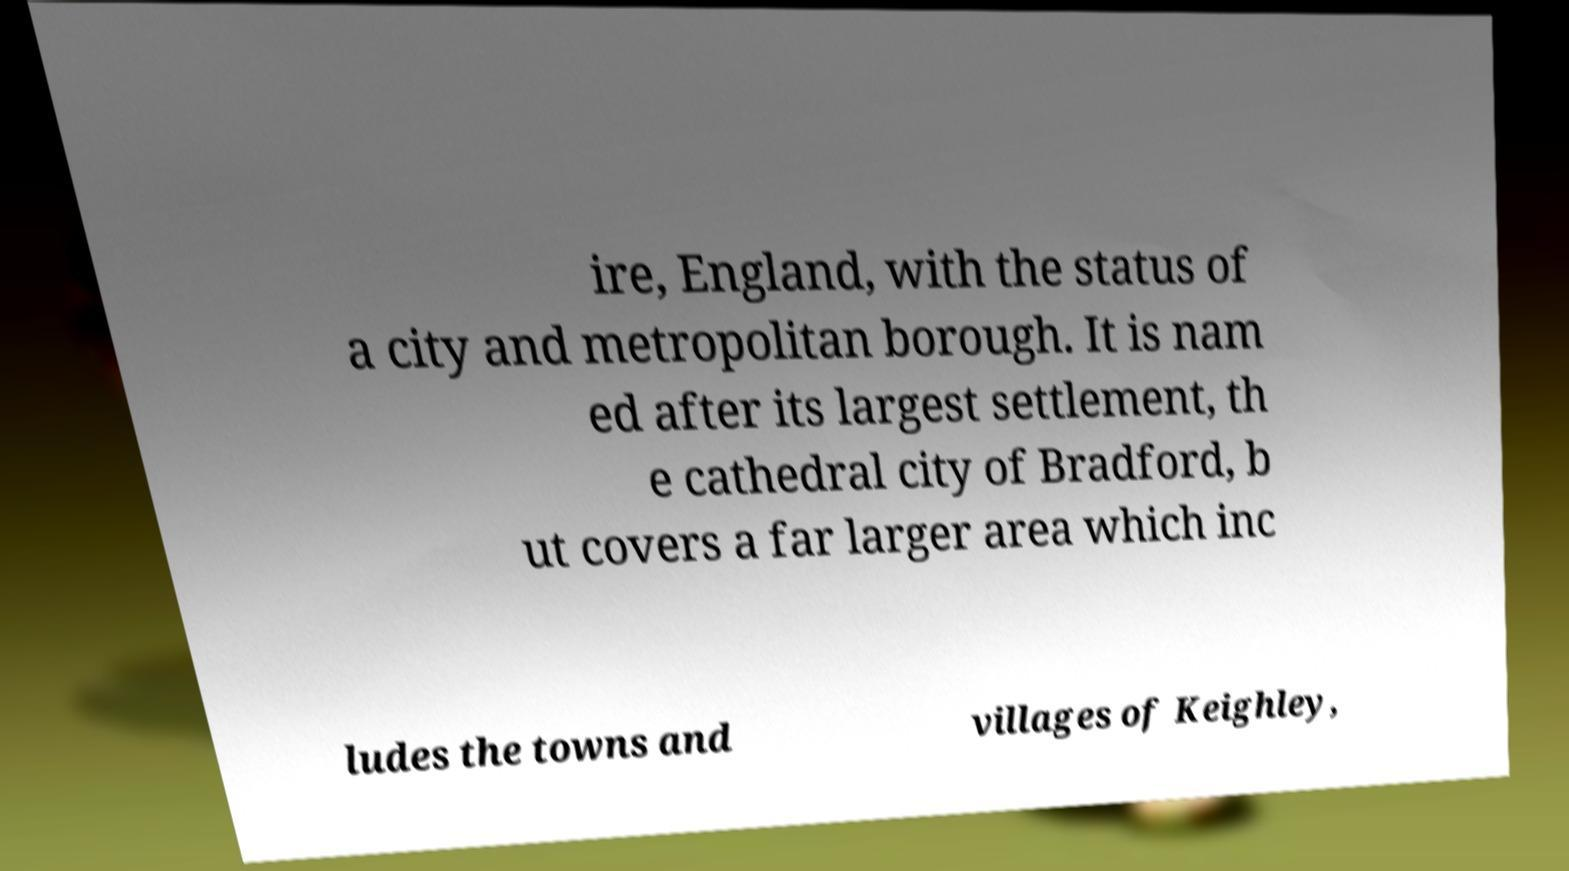For documentation purposes, I need the text within this image transcribed. Could you provide that? ire, England, with the status of a city and metropolitan borough. It is nam ed after its largest settlement, th e cathedral city of Bradford, b ut covers a far larger area which inc ludes the towns and villages of Keighley, 